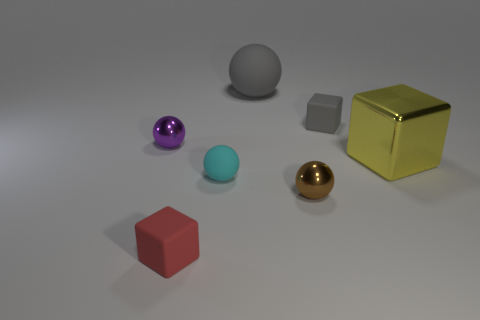Does the small brown metal object have the same shape as the tiny gray thing in front of the gray ball?
Ensure brevity in your answer.  No. How many other objects are the same size as the gray matte ball?
Provide a succinct answer. 1. Are there more purple shiny objects than small purple rubber things?
Your answer should be compact. Yes. How many small objects are to the right of the red cube and behind the brown thing?
Ensure brevity in your answer.  2. There is a gray object that is left of the rubber cube that is on the right side of the shiny ball that is on the right side of the gray ball; what shape is it?
Your answer should be very brief. Sphere. Is there anything else that is the same shape as the tiny cyan object?
Your answer should be compact. Yes. What number of blocks are large cyan things or gray rubber things?
Make the answer very short. 1. There is a tiny cube that is behind the red matte block; does it have the same color as the large sphere?
Your answer should be very brief. Yes. There is a big object right of the metal ball that is to the right of the matte cube that is in front of the tiny gray object; what is it made of?
Keep it short and to the point. Metal. Is the brown shiny object the same size as the purple object?
Provide a short and direct response. Yes. 